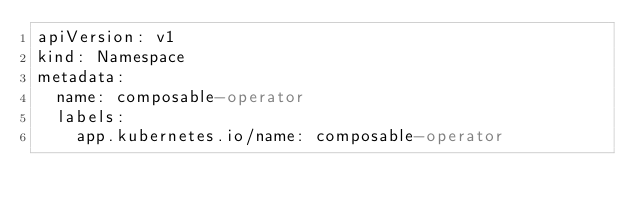Convert code to text. <code><loc_0><loc_0><loc_500><loc_500><_YAML_>apiVersion: v1
kind: Namespace
metadata:
  name: composable-operator
  labels:
    app.kubernetes.io/name: composable-operator</code> 